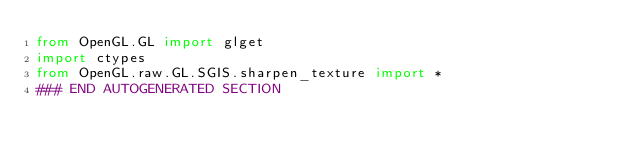<code> <loc_0><loc_0><loc_500><loc_500><_Python_>from OpenGL.GL import glget
import ctypes
from OpenGL.raw.GL.SGIS.sharpen_texture import *
### END AUTOGENERATED SECTION</code> 